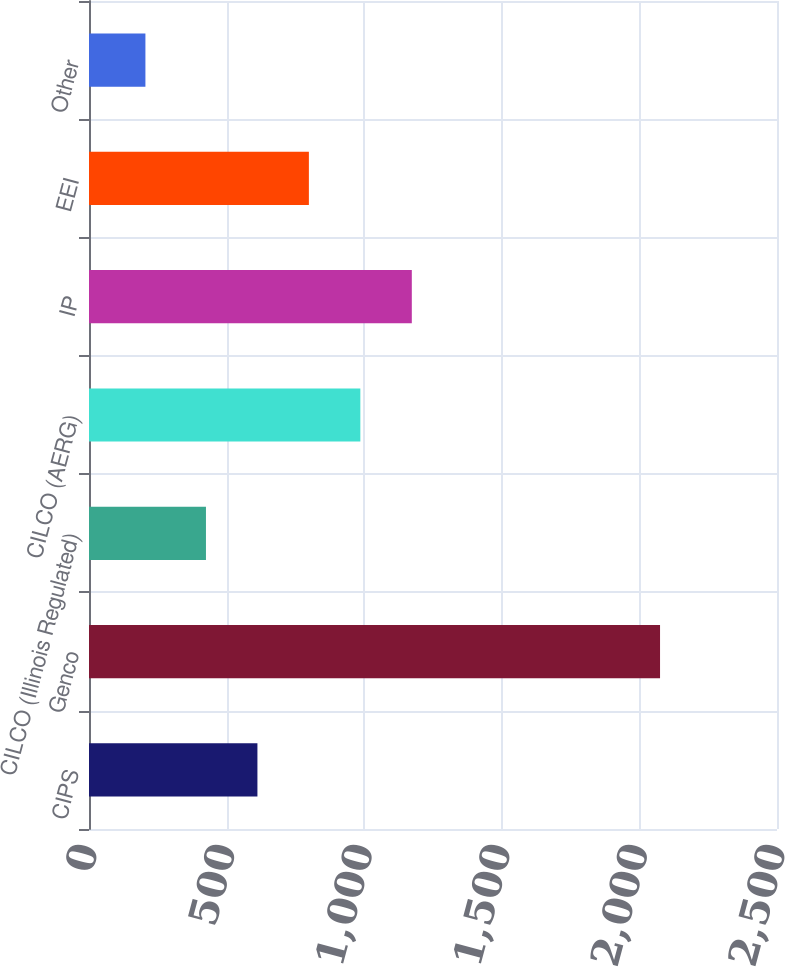<chart> <loc_0><loc_0><loc_500><loc_500><bar_chart><fcel>CIPS<fcel>Genco<fcel>CILCO (Illinois Regulated)<fcel>CILCO (AERG)<fcel>IP<fcel>EEI<fcel>Other<nl><fcel>612<fcel>2075<fcel>425<fcel>986<fcel>1173<fcel>799<fcel>205<nl></chart> 